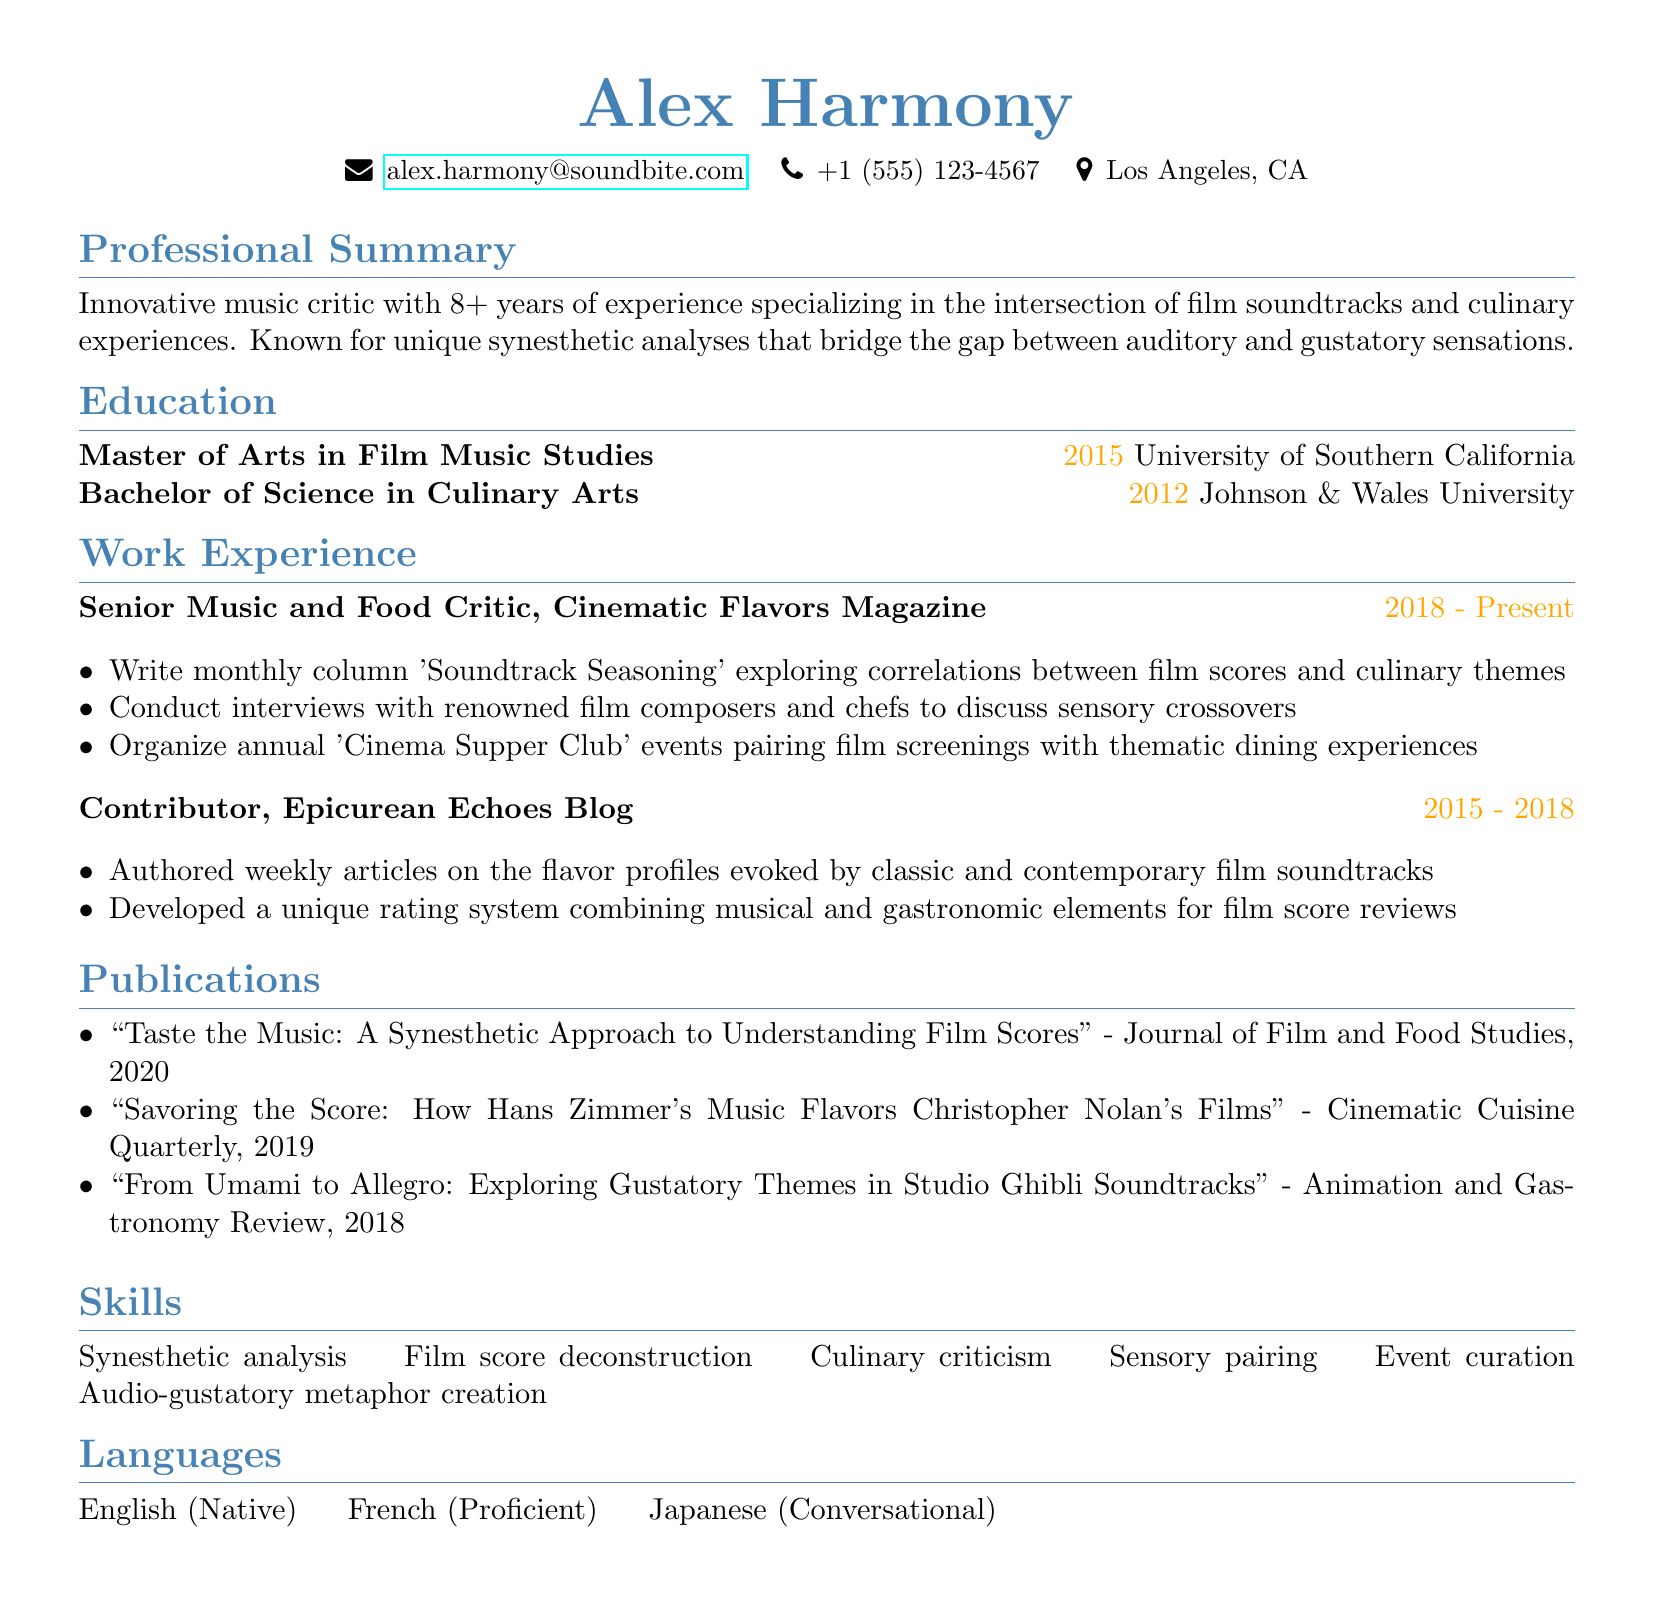What is Alex Harmony's email? Alex Harmony's email is directly stated in the document under personal information.
Answer: alex.harmony@soundbite.com What position does Alex Harmony currently hold? The current position of Alex Harmony is mentioned in the work experience section of the CV.
Answer: Senior Music and Food Critic Which university did Alex Harmony attend for a Master's degree? The document lists the institutions where degrees were obtained, specifically mentioning the university for the Master's degree.
Answer: University of Southern California What is the title of the publication from 2020? The document outlines the titles of publications in the publications section, specifically highlighting the year 2020.
Answer: "Taste the Music: A Synesthetic Approach to Understanding Film Scores" How many years of experience does Alex Harmony have? The professional summary indicates the number of years Alex Harmony has been working in the relevant field.
Answer: 8+ What does the 'Soundtrack Seasoning' column explore? The responsibilities in the work experience section detail the focus of the 'Soundtrack Seasoning' column.
Answer: Correlations between film scores and culinary themes What unique system did Alex Harmony develop for film score reviews? The contributor's responsibilities mention a specific system created for reviews in the Epicurean Echoes Blog.
Answer: Unique rating system combining musical and gastronomic elements In which languages is Alex Harmony proficient? The languages section lists the languages Alex Harmony can communicate in, indicating proficiency.
Answer: English, French, Japanese 